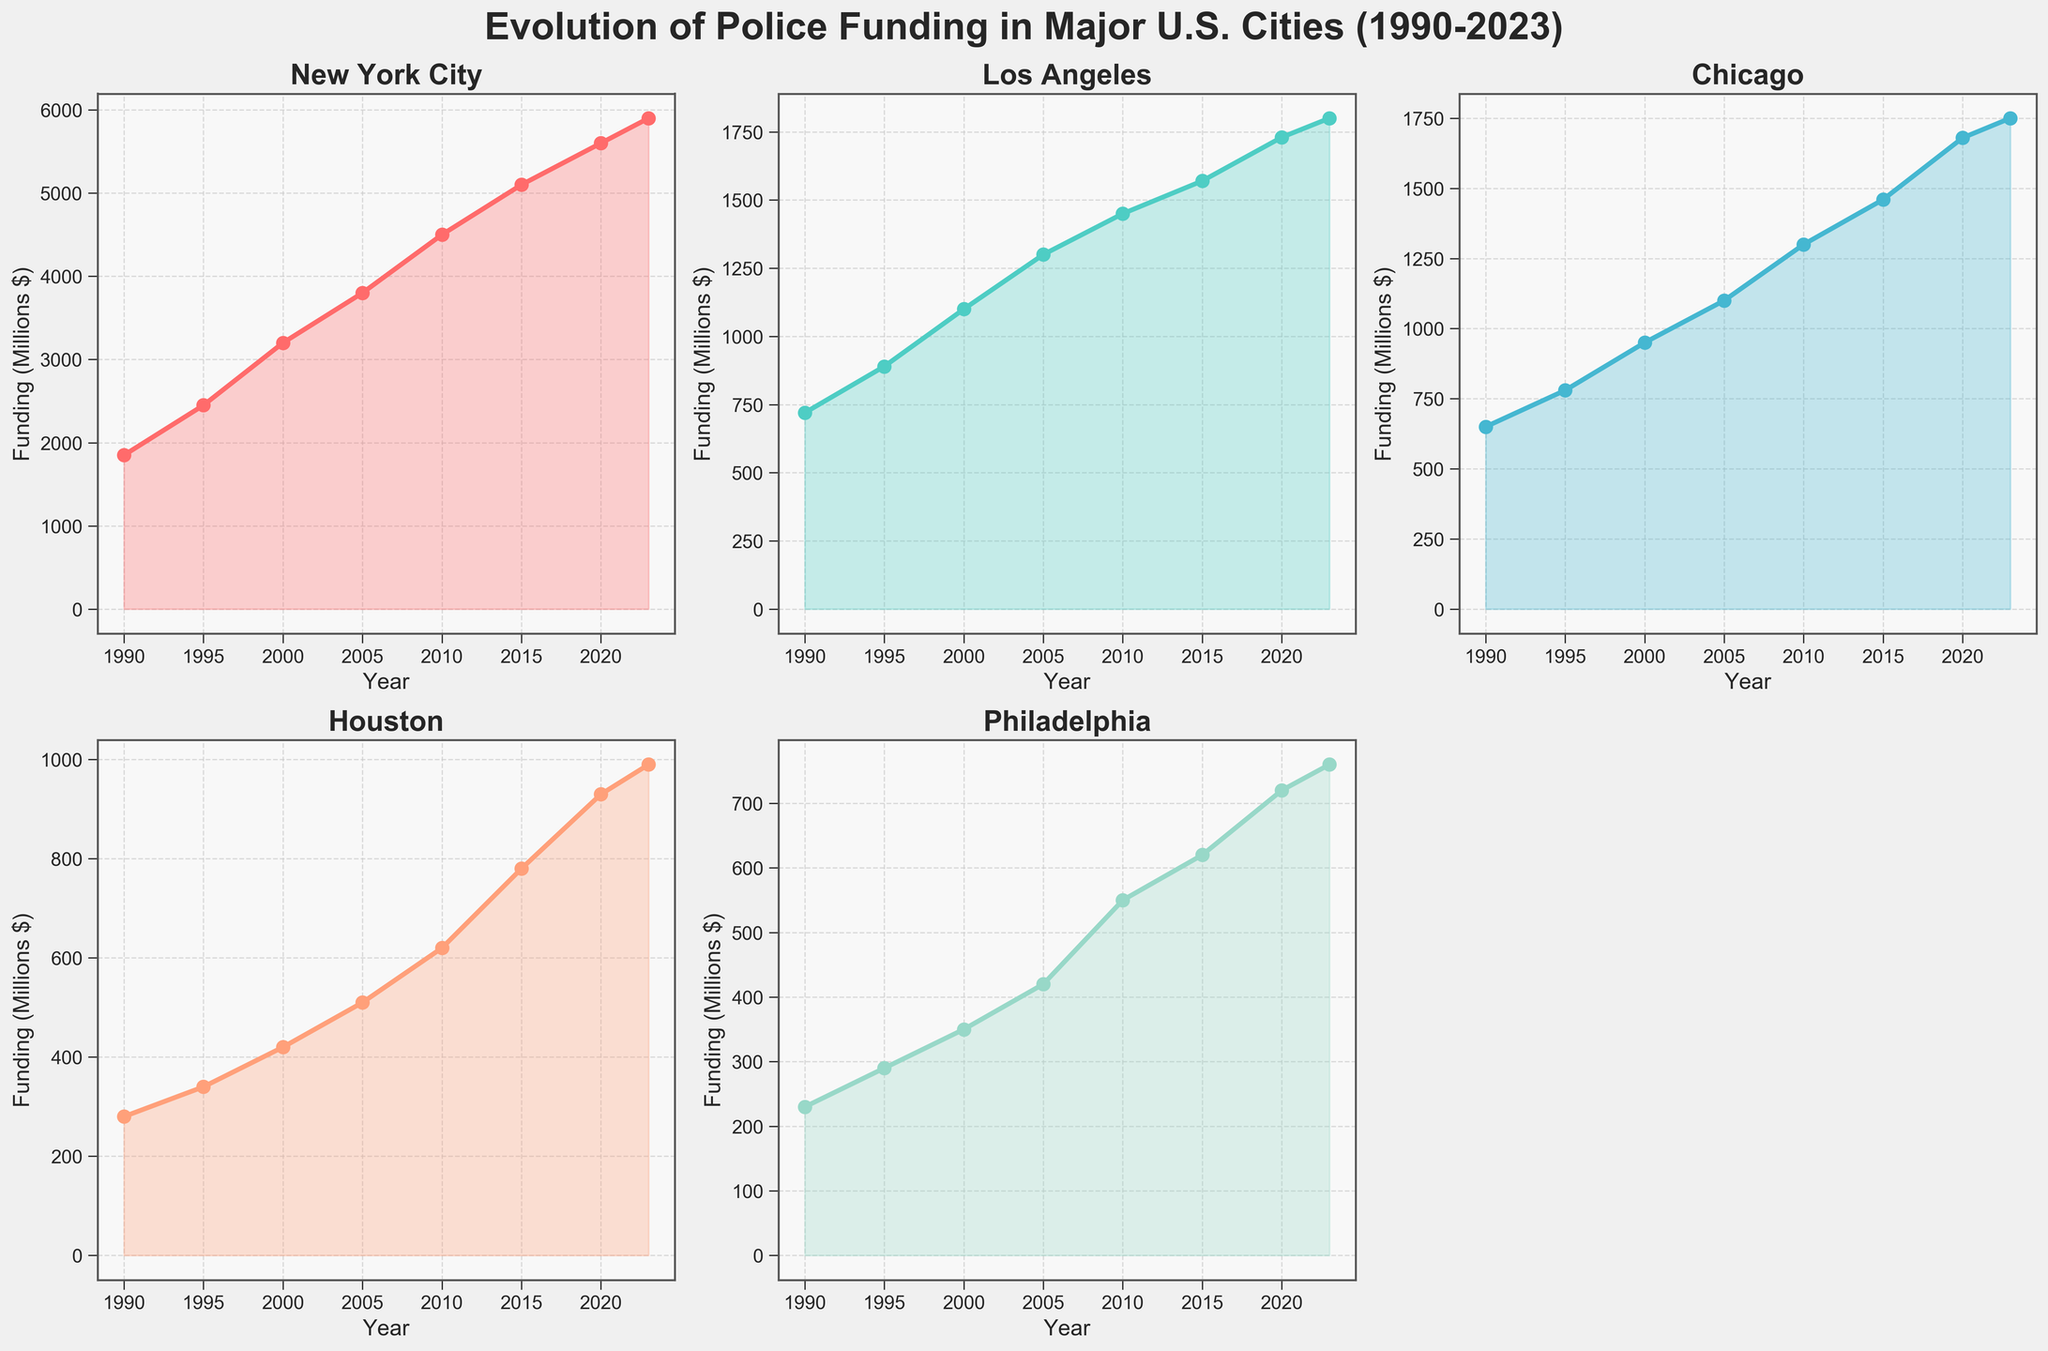What's the city with the highest police funding in 2023? In the figure, we see the funding values at the end of the timeline for each city. New York City has the highest police funding with a value of 5900 million dollars.
Answer: New York City How much did Houston's police funding increase from 1990 to 2023? To find the increase, subtract the 1990 value from the 2023 value for Houston. The values are 990 million dollars in 2023 and 280 million dollars in 1990. The difference is 990 - 280 = 710 million dollars.
Answer: 710 million dollars Which city has shown the steepest increase in police funding from 1995 to 2020? By looking at the slope of the lines from 1995 to 2020, New York City shows the steepest increase. The funding increased from 2450 million dollars in 1995 to 5600 million dollars in 2020.
Answer: New York City What is the average police funding for Chicago between 1990 and 2020? Add the funding amounts for Chicago from 1990 to 2020 and divide by the number of data points (8). The values are 650, 780, 950, 1100, 1300, 1460, 1680, 1750. The sum is 10670, and 10670/8 = 1333.75 million dollars.
Answer: 1333.75 million dollars Compare the total increase in police funding between Los Angeles and Philadelphia from 1990 to 2023. Which city had a greater increase? Subtract the 1990 value from the 2023 value for both cities. For Los Angeles, it is 1800 - 720 = 1080 million dollars. For Philadelphia, it is 760 - 230 = 530 million dollars. Los Angeles had a greater increase.
Answer: Los Angeles What visual patterns can be observed with respect to the colors used in the plots? Each city’s line plot has a distinct color, making it easy to differentiate between them. There are fill areas under the lines that help emphasize trends over time.
Answer: Distinct colors for each city, filled areas under lines Is there any city that experienced a decrease in police funding at any point in the shown timeline? By visually inspecting the plots, no city shows a decrease; all cities have an increasing trend in police funding from 1990 to 2023.
Answer: No Which city had the lowest police funding in 2000 and what was the amount? Looking at the points for the year 2000 across all the plots, Philadelphia had the lowest police funding of 350 million dollars.
Answer: Philadelphia, 350 million dollars Compare the police funding trend of New York City and Houston. How do their growth rates differ? New York City’s plot shows a consistently higher and steeper increase in police funding over the years compared to Houston, which has a more gradual increase, especially before 2015. Houston’s significant growth begins around 2015.
Answer: New York City's growth is steeper What was the combined police funding of New York City and Los Angeles in 2010? Add the police funding values for both cities in 2010: New York City with 4500 million dollars and Los Angeles with 1450 million dollars. The sum is 4500 + 1450 = 5950 million dollars.
Answer: 5950 million dollars 